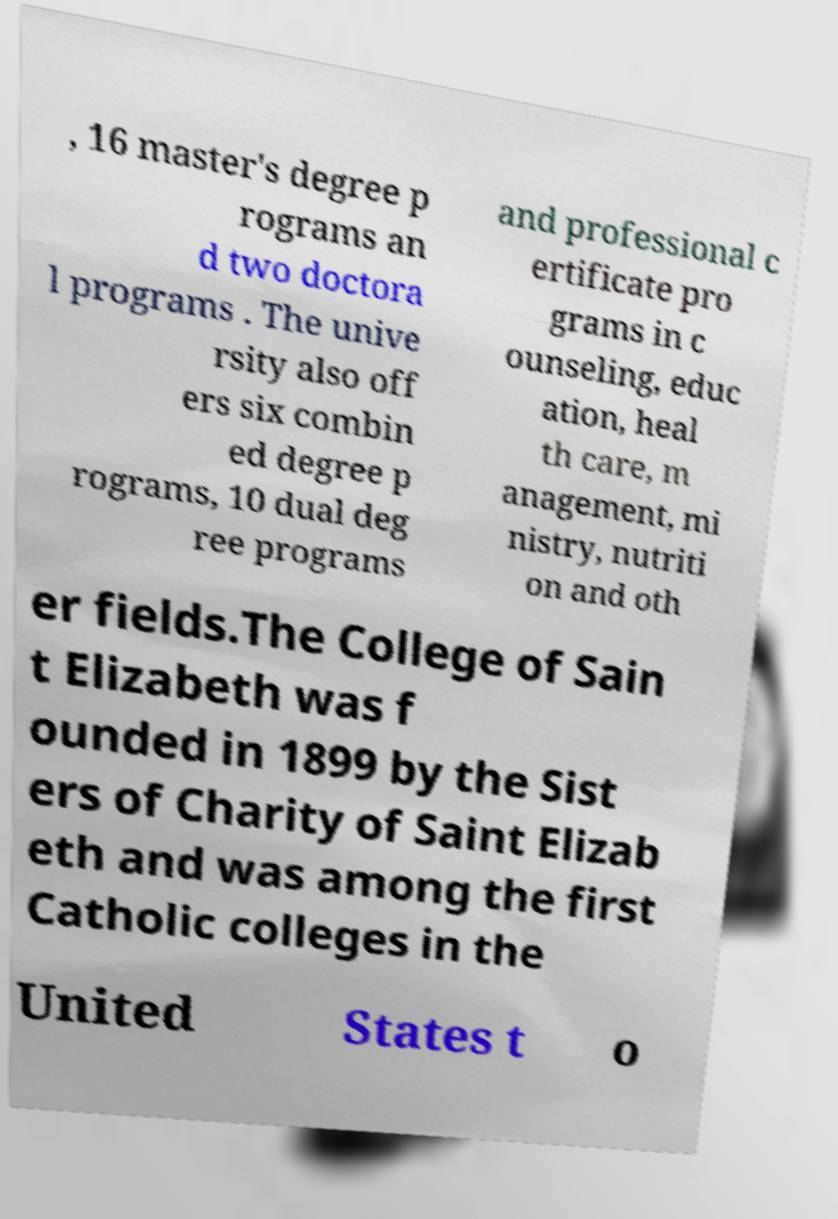Could you extract and type out the text from this image? , 16 master's degree p rograms an d two doctora l programs . The unive rsity also off ers six combin ed degree p rograms, 10 dual deg ree programs and professional c ertificate pro grams in c ounseling, educ ation, heal th care, m anagement, mi nistry, nutriti on and oth er fields.The College of Sain t Elizabeth was f ounded in 1899 by the Sist ers of Charity of Saint Elizab eth and was among the first Catholic colleges in the United States t o 